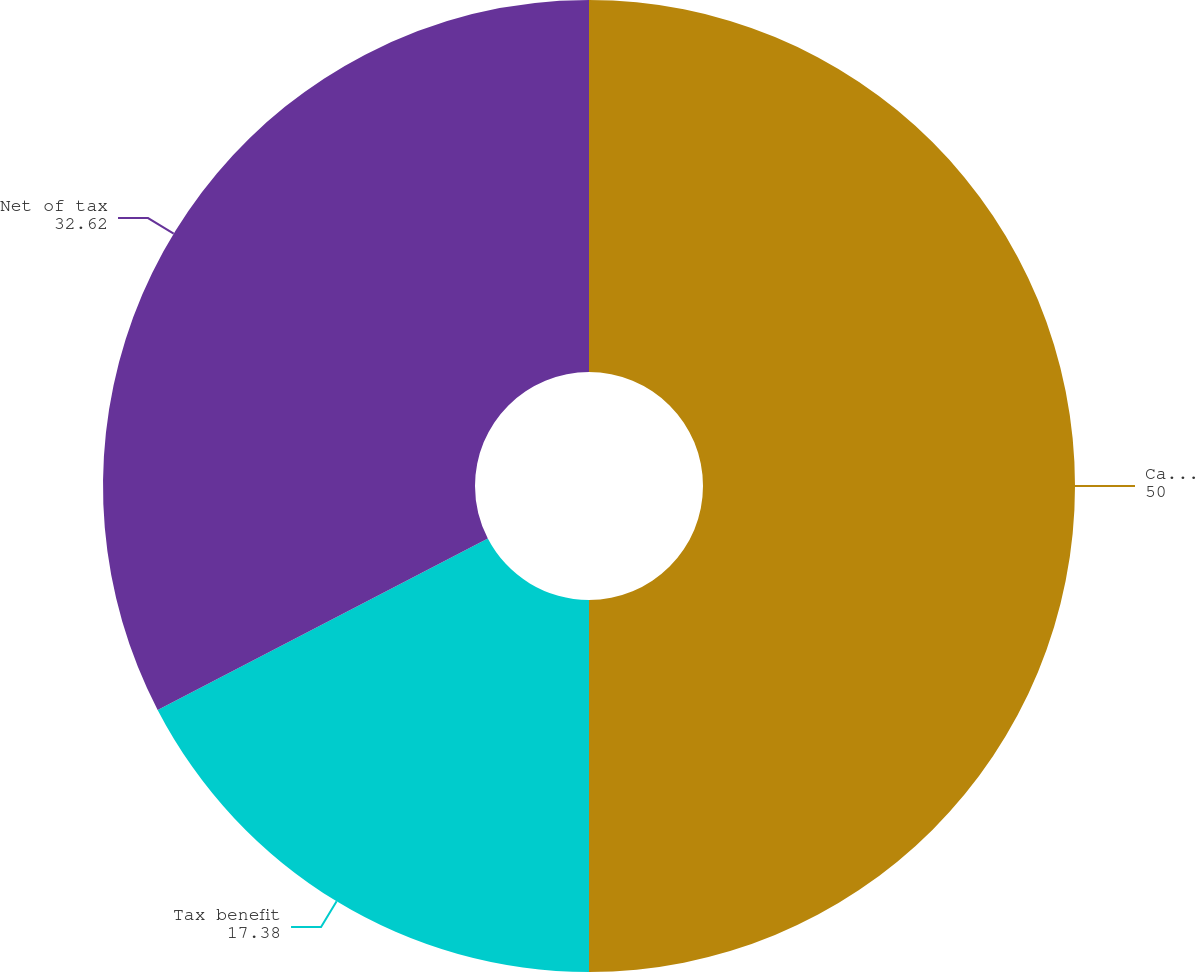Convert chart. <chart><loc_0><loc_0><loc_500><loc_500><pie_chart><fcel>Cash flow hedges Net gains<fcel>Tax benefit<fcel>Net of tax<nl><fcel>50.0%<fcel>17.38%<fcel>32.62%<nl></chart> 